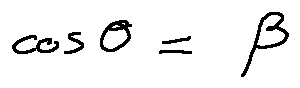<formula> <loc_0><loc_0><loc_500><loc_500>\cos \theta = \beta</formula> 